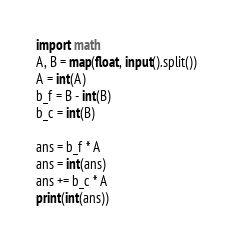<code> <loc_0><loc_0><loc_500><loc_500><_Python_>import math
A, B = map(float, input().split())
A = int(A)
b_f = B - int(B)
b_c = int(B)

ans = b_f * A
ans = int(ans)
ans += b_c * A
print(int(ans))</code> 